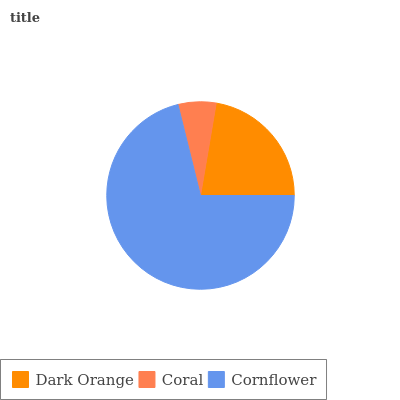Is Coral the minimum?
Answer yes or no. Yes. Is Cornflower the maximum?
Answer yes or no. Yes. Is Cornflower the minimum?
Answer yes or no. No. Is Coral the maximum?
Answer yes or no. No. Is Cornflower greater than Coral?
Answer yes or no. Yes. Is Coral less than Cornflower?
Answer yes or no. Yes. Is Coral greater than Cornflower?
Answer yes or no. No. Is Cornflower less than Coral?
Answer yes or no. No. Is Dark Orange the high median?
Answer yes or no. Yes. Is Dark Orange the low median?
Answer yes or no. Yes. Is Coral the high median?
Answer yes or no. No. Is Cornflower the low median?
Answer yes or no. No. 